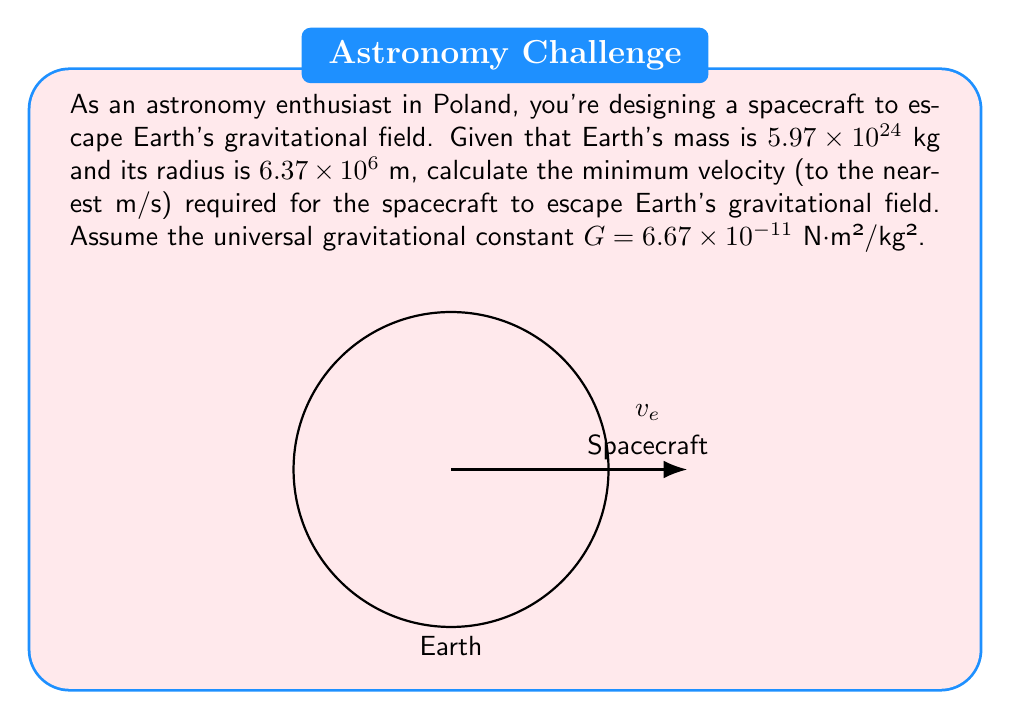Help me with this question. To solve this problem, we'll use the escape velocity formula:

$$ v_e = \sqrt{\frac{2GM}{R}} $$

Where:
$v_e$ is the escape velocity
$G$ is the universal gravitational constant
$M$ is the mass of Earth
$R$ is the radius of Earth

Let's substitute the given values:

$G = 6.67 \times 10^{-11}$ N⋅m²/kg²
$M = 5.97 \times 10^{24}$ kg
$R = 6.37 \times 10^6$ m

Now, let's calculate step by step:

1) First, multiply 2 by G and M:
   $2GM = 2 \times (6.67 \times 10^{-11}) \times (5.97 \times 10^{24}) = 7.96 \times 10^{14}$ N⋅m²/kg

2) Now divide this by R:
   $\frac{2GM}{R} = \frac{7.96 \times 10^{14}}{6.37 \times 10^6} = 1.25 \times 10^{8}$ m²/s²

3) Finally, take the square root:
   $v_e = \sqrt{1.25 \times 10^{8}} = 11,179.5$ m/s

4) Rounding to the nearest m/s:
   $v_e \approx 11,180$ m/s
Answer: 11,180 m/s 